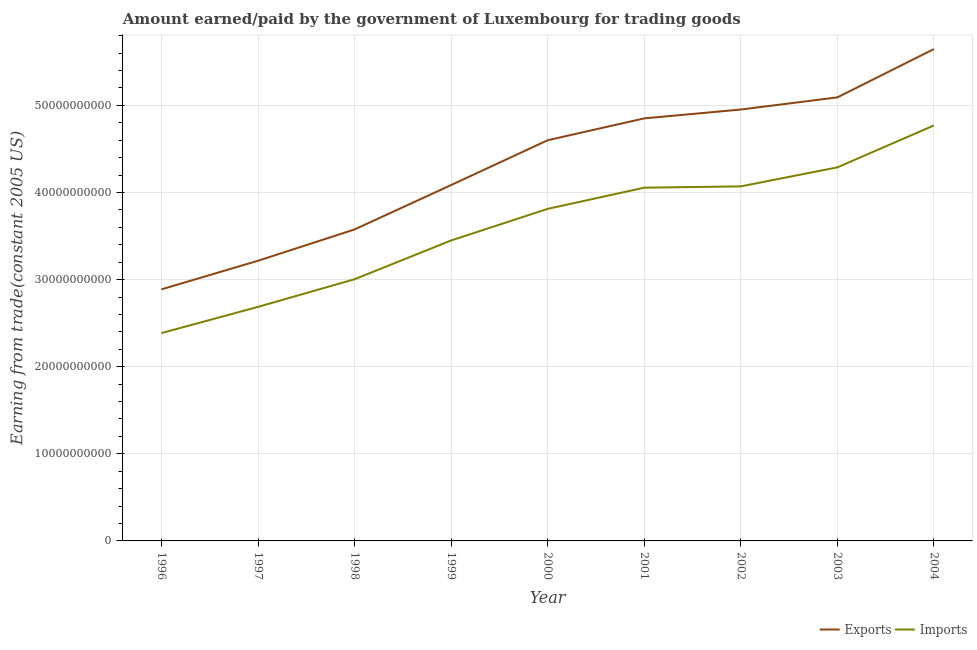Does the line corresponding to amount earned from exports intersect with the line corresponding to amount paid for imports?
Offer a terse response. No. What is the amount paid for imports in 1996?
Provide a succinct answer. 2.39e+1. Across all years, what is the maximum amount paid for imports?
Ensure brevity in your answer.  4.77e+1. Across all years, what is the minimum amount paid for imports?
Keep it short and to the point. 2.39e+1. In which year was the amount earned from exports maximum?
Your response must be concise. 2004. In which year was the amount paid for imports minimum?
Keep it short and to the point. 1996. What is the total amount paid for imports in the graph?
Offer a terse response. 3.25e+11. What is the difference between the amount paid for imports in 1996 and that in 1997?
Your answer should be very brief. -3.01e+09. What is the difference between the amount earned from exports in 1999 and the amount paid for imports in 2004?
Your answer should be very brief. -6.84e+09. What is the average amount earned from exports per year?
Keep it short and to the point. 4.32e+1. In the year 1998, what is the difference between the amount earned from exports and amount paid for imports?
Make the answer very short. 5.72e+09. What is the ratio of the amount earned from exports in 1996 to that in 1998?
Make the answer very short. 0.81. Is the amount paid for imports in 2003 less than that in 2004?
Your answer should be very brief. Yes. Is the difference between the amount paid for imports in 2000 and 2002 greater than the difference between the amount earned from exports in 2000 and 2002?
Your answer should be very brief. Yes. What is the difference between the highest and the second highest amount paid for imports?
Your response must be concise. 4.81e+09. What is the difference between the highest and the lowest amount earned from exports?
Make the answer very short. 2.76e+1. In how many years, is the amount paid for imports greater than the average amount paid for imports taken over all years?
Your response must be concise. 5. Is the sum of the amount paid for imports in 1999 and 2004 greater than the maximum amount earned from exports across all years?
Offer a very short reply. Yes. Is the amount paid for imports strictly greater than the amount earned from exports over the years?
Provide a succinct answer. No. What is the difference between two consecutive major ticks on the Y-axis?
Offer a terse response. 1.00e+1. Are the values on the major ticks of Y-axis written in scientific E-notation?
Provide a short and direct response. No. How many legend labels are there?
Offer a terse response. 2. What is the title of the graph?
Your answer should be very brief. Amount earned/paid by the government of Luxembourg for trading goods. Does "% of gross capital formation" appear as one of the legend labels in the graph?
Provide a succinct answer. No. What is the label or title of the Y-axis?
Make the answer very short. Earning from trade(constant 2005 US). What is the Earning from trade(constant 2005 US) in Exports in 1996?
Your answer should be compact. 2.89e+1. What is the Earning from trade(constant 2005 US) in Imports in 1996?
Your answer should be very brief. 2.39e+1. What is the Earning from trade(constant 2005 US) in Exports in 1997?
Make the answer very short. 3.22e+1. What is the Earning from trade(constant 2005 US) in Imports in 1997?
Ensure brevity in your answer.  2.69e+1. What is the Earning from trade(constant 2005 US) in Exports in 1998?
Give a very brief answer. 3.58e+1. What is the Earning from trade(constant 2005 US) of Imports in 1998?
Your response must be concise. 3.00e+1. What is the Earning from trade(constant 2005 US) of Exports in 1999?
Make the answer very short. 4.09e+1. What is the Earning from trade(constant 2005 US) in Imports in 1999?
Your response must be concise. 3.45e+1. What is the Earning from trade(constant 2005 US) of Exports in 2000?
Keep it short and to the point. 4.60e+1. What is the Earning from trade(constant 2005 US) in Imports in 2000?
Provide a succinct answer. 3.81e+1. What is the Earning from trade(constant 2005 US) of Exports in 2001?
Offer a very short reply. 4.85e+1. What is the Earning from trade(constant 2005 US) of Imports in 2001?
Your response must be concise. 4.06e+1. What is the Earning from trade(constant 2005 US) in Exports in 2002?
Provide a succinct answer. 4.95e+1. What is the Earning from trade(constant 2005 US) of Imports in 2002?
Your answer should be very brief. 4.07e+1. What is the Earning from trade(constant 2005 US) of Exports in 2003?
Keep it short and to the point. 5.09e+1. What is the Earning from trade(constant 2005 US) of Imports in 2003?
Make the answer very short. 4.29e+1. What is the Earning from trade(constant 2005 US) of Exports in 2004?
Offer a terse response. 5.65e+1. What is the Earning from trade(constant 2005 US) of Imports in 2004?
Give a very brief answer. 4.77e+1. Across all years, what is the maximum Earning from trade(constant 2005 US) in Exports?
Your response must be concise. 5.65e+1. Across all years, what is the maximum Earning from trade(constant 2005 US) of Imports?
Ensure brevity in your answer.  4.77e+1. Across all years, what is the minimum Earning from trade(constant 2005 US) in Exports?
Your response must be concise. 2.89e+1. Across all years, what is the minimum Earning from trade(constant 2005 US) in Imports?
Your answer should be compact. 2.39e+1. What is the total Earning from trade(constant 2005 US) in Exports in the graph?
Offer a terse response. 3.89e+11. What is the total Earning from trade(constant 2005 US) in Imports in the graph?
Give a very brief answer. 3.25e+11. What is the difference between the Earning from trade(constant 2005 US) of Exports in 1996 and that in 1997?
Make the answer very short. -3.28e+09. What is the difference between the Earning from trade(constant 2005 US) in Imports in 1996 and that in 1997?
Ensure brevity in your answer.  -3.01e+09. What is the difference between the Earning from trade(constant 2005 US) in Exports in 1996 and that in 1998?
Make the answer very short. -6.88e+09. What is the difference between the Earning from trade(constant 2005 US) in Imports in 1996 and that in 1998?
Your answer should be very brief. -6.18e+09. What is the difference between the Earning from trade(constant 2005 US) of Exports in 1996 and that in 1999?
Your answer should be compact. -1.20e+1. What is the difference between the Earning from trade(constant 2005 US) of Imports in 1996 and that in 1999?
Ensure brevity in your answer.  -1.06e+1. What is the difference between the Earning from trade(constant 2005 US) in Exports in 1996 and that in 2000?
Make the answer very short. -1.71e+1. What is the difference between the Earning from trade(constant 2005 US) of Imports in 1996 and that in 2000?
Offer a terse response. -1.43e+1. What is the difference between the Earning from trade(constant 2005 US) of Exports in 1996 and that in 2001?
Provide a short and direct response. -1.96e+1. What is the difference between the Earning from trade(constant 2005 US) of Imports in 1996 and that in 2001?
Make the answer very short. -1.67e+1. What is the difference between the Earning from trade(constant 2005 US) in Exports in 1996 and that in 2002?
Ensure brevity in your answer.  -2.06e+1. What is the difference between the Earning from trade(constant 2005 US) of Imports in 1996 and that in 2002?
Give a very brief answer. -1.68e+1. What is the difference between the Earning from trade(constant 2005 US) of Exports in 1996 and that in 2003?
Provide a short and direct response. -2.20e+1. What is the difference between the Earning from trade(constant 2005 US) in Imports in 1996 and that in 2003?
Ensure brevity in your answer.  -1.90e+1. What is the difference between the Earning from trade(constant 2005 US) of Exports in 1996 and that in 2004?
Your answer should be compact. -2.76e+1. What is the difference between the Earning from trade(constant 2005 US) of Imports in 1996 and that in 2004?
Your answer should be very brief. -2.38e+1. What is the difference between the Earning from trade(constant 2005 US) in Exports in 1997 and that in 1998?
Keep it short and to the point. -3.59e+09. What is the difference between the Earning from trade(constant 2005 US) of Imports in 1997 and that in 1998?
Provide a short and direct response. -3.17e+09. What is the difference between the Earning from trade(constant 2005 US) in Exports in 1997 and that in 1999?
Your answer should be compact. -8.69e+09. What is the difference between the Earning from trade(constant 2005 US) in Imports in 1997 and that in 1999?
Your response must be concise. -7.63e+09. What is the difference between the Earning from trade(constant 2005 US) of Exports in 1997 and that in 2000?
Your answer should be very brief. -1.38e+1. What is the difference between the Earning from trade(constant 2005 US) of Imports in 1997 and that in 2000?
Your response must be concise. -1.13e+1. What is the difference between the Earning from trade(constant 2005 US) of Exports in 1997 and that in 2001?
Your answer should be compact. -1.63e+1. What is the difference between the Earning from trade(constant 2005 US) of Imports in 1997 and that in 2001?
Ensure brevity in your answer.  -1.37e+1. What is the difference between the Earning from trade(constant 2005 US) of Exports in 1997 and that in 2002?
Your answer should be compact. -1.74e+1. What is the difference between the Earning from trade(constant 2005 US) in Imports in 1997 and that in 2002?
Give a very brief answer. -1.38e+1. What is the difference between the Earning from trade(constant 2005 US) in Exports in 1997 and that in 2003?
Offer a very short reply. -1.88e+1. What is the difference between the Earning from trade(constant 2005 US) of Imports in 1997 and that in 2003?
Offer a very short reply. -1.60e+1. What is the difference between the Earning from trade(constant 2005 US) in Exports in 1997 and that in 2004?
Ensure brevity in your answer.  -2.43e+1. What is the difference between the Earning from trade(constant 2005 US) in Imports in 1997 and that in 2004?
Give a very brief answer. -2.08e+1. What is the difference between the Earning from trade(constant 2005 US) of Exports in 1998 and that in 1999?
Your answer should be very brief. -5.10e+09. What is the difference between the Earning from trade(constant 2005 US) of Imports in 1998 and that in 1999?
Offer a very short reply. -4.45e+09. What is the difference between the Earning from trade(constant 2005 US) of Exports in 1998 and that in 2000?
Offer a terse response. -1.02e+1. What is the difference between the Earning from trade(constant 2005 US) in Imports in 1998 and that in 2000?
Keep it short and to the point. -8.08e+09. What is the difference between the Earning from trade(constant 2005 US) of Exports in 1998 and that in 2001?
Give a very brief answer. -1.28e+1. What is the difference between the Earning from trade(constant 2005 US) in Imports in 1998 and that in 2001?
Give a very brief answer. -1.05e+1. What is the difference between the Earning from trade(constant 2005 US) of Exports in 1998 and that in 2002?
Provide a succinct answer. -1.38e+1. What is the difference between the Earning from trade(constant 2005 US) of Imports in 1998 and that in 2002?
Your answer should be compact. -1.07e+1. What is the difference between the Earning from trade(constant 2005 US) of Exports in 1998 and that in 2003?
Offer a very short reply. -1.52e+1. What is the difference between the Earning from trade(constant 2005 US) in Imports in 1998 and that in 2003?
Make the answer very short. -1.28e+1. What is the difference between the Earning from trade(constant 2005 US) in Exports in 1998 and that in 2004?
Provide a short and direct response. -2.07e+1. What is the difference between the Earning from trade(constant 2005 US) of Imports in 1998 and that in 2004?
Make the answer very short. -1.77e+1. What is the difference between the Earning from trade(constant 2005 US) in Exports in 1999 and that in 2000?
Offer a terse response. -5.15e+09. What is the difference between the Earning from trade(constant 2005 US) of Imports in 1999 and that in 2000?
Offer a terse response. -3.63e+09. What is the difference between the Earning from trade(constant 2005 US) in Exports in 1999 and that in 2001?
Your answer should be very brief. -7.65e+09. What is the difference between the Earning from trade(constant 2005 US) of Imports in 1999 and that in 2001?
Make the answer very short. -6.06e+09. What is the difference between the Earning from trade(constant 2005 US) of Exports in 1999 and that in 2002?
Ensure brevity in your answer.  -8.67e+09. What is the difference between the Earning from trade(constant 2005 US) in Imports in 1999 and that in 2002?
Keep it short and to the point. -6.21e+09. What is the difference between the Earning from trade(constant 2005 US) of Exports in 1999 and that in 2003?
Provide a succinct answer. -1.01e+1. What is the difference between the Earning from trade(constant 2005 US) of Imports in 1999 and that in 2003?
Provide a succinct answer. -8.39e+09. What is the difference between the Earning from trade(constant 2005 US) of Exports in 1999 and that in 2004?
Your answer should be very brief. -1.56e+1. What is the difference between the Earning from trade(constant 2005 US) in Imports in 1999 and that in 2004?
Make the answer very short. -1.32e+1. What is the difference between the Earning from trade(constant 2005 US) of Exports in 2000 and that in 2001?
Your answer should be compact. -2.51e+09. What is the difference between the Earning from trade(constant 2005 US) of Imports in 2000 and that in 2001?
Provide a short and direct response. -2.43e+09. What is the difference between the Earning from trade(constant 2005 US) of Exports in 2000 and that in 2002?
Your answer should be compact. -3.52e+09. What is the difference between the Earning from trade(constant 2005 US) in Imports in 2000 and that in 2002?
Ensure brevity in your answer.  -2.58e+09. What is the difference between the Earning from trade(constant 2005 US) in Exports in 2000 and that in 2003?
Ensure brevity in your answer.  -4.92e+09. What is the difference between the Earning from trade(constant 2005 US) of Imports in 2000 and that in 2003?
Ensure brevity in your answer.  -4.76e+09. What is the difference between the Earning from trade(constant 2005 US) in Exports in 2000 and that in 2004?
Provide a short and direct response. -1.05e+1. What is the difference between the Earning from trade(constant 2005 US) of Imports in 2000 and that in 2004?
Your answer should be very brief. -9.58e+09. What is the difference between the Earning from trade(constant 2005 US) of Exports in 2001 and that in 2002?
Your answer should be compact. -1.02e+09. What is the difference between the Earning from trade(constant 2005 US) in Imports in 2001 and that in 2002?
Offer a terse response. -1.50e+08. What is the difference between the Earning from trade(constant 2005 US) in Exports in 2001 and that in 2003?
Your answer should be compact. -2.41e+09. What is the difference between the Earning from trade(constant 2005 US) of Imports in 2001 and that in 2003?
Provide a succinct answer. -2.33e+09. What is the difference between the Earning from trade(constant 2005 US) in Exports in 2001 and that in 2004?
Keep it short and to the point. -7.96e+09. What is the difference between the Earning from trade(constant 2005 US) of Imports in 2001 and that in 2004?
Provide a short and direct response. -7.14e+09. What is the difference between the Earning from trade(constant 2005 US) in Exports in 2002 and that in 2003?
Make the answer very short. -1.39e+09. What is the difference between the Earning from trade(constant 2005 US) in Imports in 2002 and that in 2003?
Your answer should be compact. -2.18e+09. What is the difference between the Earning from trade(constant 2005 US) of Exports in 2002 and that in 2004?
Give a very brief answer. -6.94e+09. What is the difference between the Earning from trade(constant 2005 US) in Imports in 2002 and that in 2004?
Provide a short and direct response. -6.99e+09. What is the difference between the Earning from trade(constant 2005 US) of Exports in 2003 and that in 2004?
Ensure brevity in your answer.  -5.55e+09. What is the difference between the Earning from trade(constant 2005 US) of Imports in 2003 and that in 2004?
Make the answer very short. -4.81e+09. What is the difference between the Earning from trade(constant 2005 US) of Exports in 1996 and the Earning from trade(constant 2005 US) of Imports in 1997?
Offer a very short reply. 2.01e+09. What is the difference between the Earning from trade(constant 2005 US) in Exports in 1996 and the Earning from trade(constant 2005 US) in Imports in 1998?
Offer a terse response. -1.16e+09. What is the difference between the Earning from trade(constant 2005 US) in Exports in 1996 and the Earning from trade(constant 2005 US) in Imports in 1999?
Offer a very short reply. -5.61e+09. What is the difference between the Earning from trade(constant 2005 US) of Exports in 1996 and the Earning from trade(constant 2005 US) of Imports in 2000?
Offer a terse response. -9.24e+09. What is the difference between the Earning from trade(constant 2005 US) in Exports in 1996 and the Earning from trade(constant 2005 US) in Imports in 2001?
Your answer should be compact. -1.17e+1. What is the difference between the Earning from trade(constant 2005 US) in Exports in 1996 and the Earning from trade(constant 2005 US) in Imports in 2002?
Ensure brevity in your answer.  -1.18e+1. What is the difference between the Earning from trade(constant 2005 US) in Exports in 1996 and the Earning from trade(constant 2005 US) in Imports in 2003?
Offer a very short reply. -1.40e+1. What is the difference between the Earning from trade(constant 2005 US) in Exports in 1996 and the Earning from trade(constant 2005 US) in Imports in 2004?
Offer a terse response. -1.88e+1. What is the difference between the Earning from trade(constant 2005 US) in Exports in 1997 and the Earning from trade(constant 2005 US) in Imports in 1998?
Ensure brevity in your answer.  2.12e+09. What is the difference between the Earning from trade(constant 2005 US) of Exports in 1997 and the Earning from trade(constant 2005 US) of Imports in 1999?
Provide a short and direct response. -2.33e+09. What is the difference between the Earning from trade(constant 2005 US) in Exports in 1997 and the Earning from trade(constant 2005 US) in Imports in 2000?
Provide a short and direct response. -5.96e+09. What is the difference between the Earning from trade(constant 2005 US) of Exports in 1997 and the Earning from trade(constant 2005 US) of Imports in 2001?
Make the answer very short. -8.39e+09. What is the difference between the Earning from trade(constant 2005 US) of Exports in 1997 and the Earning from trade(constant 2005 US) of Imports in 2002?
Your answer should be compact. -8.54e+09. What is the difference between the Earning from trade(constant 2005 US) of Exports in 1997 and the Earning from trade(constant 2005 US) of Imports in 2003?
Provide a short and direct response. -1.07e+1. What is the difference between the Earning from trade(constant 2005 US) of Exports in 1997 and the Earning from trade(constant 2005 US) of Imports in 2004?
Keep it short and to the point. -1.55e+1. What is the difference between the Earning from trade(constant 2005 US) in Exports in 1998 and the Earning from trade(constant 2005 US) in Imports in 1999?
Make the answer very short. 1.26e+09. What is the difference between the Earning from trade(constant 2005 US) of Exports in 1998 and the Earning from trade(constant 2005 US) of Imports in 2000?
Keep it short and to the point. -2.36e+09. What is the difference between the Earning from trade(constant 2005 US) of Exports in 1998 and the Earning from trade(constant 2005 US) of Imports in 2001?
Give a very brief answer. -4.79e+09. What is the difference between the Earning from trade(constant 2005 US) in Exports in 1998 and the Earning from trade(constant 2005 US) in Imports in 2002?
Your answer should be compact. -4.94e+09. What is the difference between the Earning from trade(constant 2005 US) in Exports in 1998 and the Earning from trade(constant 2005 US) in Imports in 2003?
Offer a very short reply. -7.13e+09. What is the difference between the Earning from trade(constant 2005 US) of Exports in 1998 and the Earning from trade(constant 2005 US) of Imports in 2004?
Ensure brevity in your answer.  -1.19e+1. What is the difference between the Earning from trade(constant 2005 US) in Exports in 1999 and the Earning from trade(constant 2005 US) in Imports in 2000?
Make the answer very short. 2.73e+09. What is the difference between the Earning from trade(constant 2005 US) of Exports in 1999 and the Earning from trade(constant 2005 US) of Imports in 2001?
Provide a short and direct response. 3.02e+08. What is the difference between the Earning from trade(constant 2005 US) in Exports in 1999 and the Earning from trade(constant 2005 US) in Imports in 2002?
Provide a succinct answer. 1.51e+08. What is the difference between the Earning from trade(constant 2005 US) in Exports in 1999 and the Earning from trade(constant 2005 US) in Imports in 2003?
Make the answer very short. -2.03e+09. What is the difference between the Earning from trade(constant 2005 US) in Exports in 1999 and the Earning from trade(constant 2005 US) in Imports in 2004?
Your response must be concise. -6.84e+09. What is the difference between the Earning from trade(constant 2005 US) of Exports in 2000 and the Earning from trade(constant 2005 US) of Imports in 2001?
Offer a very short reply. 5.45e+09. What is the difference between the Earning from trade(constant 2005 US) of Exports in 2000 and the Earning from trade(constant 2005 US) of Imports in 2002?
Make the answer very short. 5.30e+09. What is the difference between the Earning from trade(constant 2005 US) in Exports in 2000 and the Earning from trade(constant 2005 US) in Imports in 2003?
Provide a succinct answer. 3.12e+09. What is the difference between the Earning from trade(constant 2005 US) of Exports in 2000 and the Earning from trade(constant 2005 US) of Imports in 2004?
Provide a succinct answer. -1.70e+09. What is the difference between the Earning from trade(constant 2005 US) of Exports in 2001 and the Earning from trade(constant 2005 US) of Imports in 2002?
Give a very brief answer. 7.81e+09. What is the difference between the Earning from trade(constant 2005 US) of Exports in 2001 and the Earning from trade(constant 2005 US) of Imports in 2003?
Your response must be concise. 5.62e+09. What is the difference between the Earning from trade(constant 2005 US) in Exports in 2001 and the Earning from trade(constant 2005 US) in Imports in 2004?
Ensure brevity in your answer.  8.12e+08. What is the difference between the Earning from trade(constant 2005 US) in Exports in 2002 and the Earning from trade(constant 2005 US) in Imports in 2003?
Provide a succinct answer. 6.64e+09. What is the difference between the Earning from trade(constant 2005 US) of Exports in 2002 and the Earning from trade(constant 2005 US) of Imports in 2004?
Offer a terse response. 1.83e+09. What is the difference between the Earning from trade(constant 2005 US) in Exports in 2003 and the Earning from trade(constant 2005 US) in Imports in 2004?
Make the answer very short. 3.22e+09. What is the average Earning from trade(constant 2005 US) in Exports per year?
Your answer should be very brief. 4.32e+1. What is the average Earning from trade(constant 2005 US) of Imports per year?
Keep it short and to the point. 3.61e+1. In the year 1996, what is the difference between the Earning from trade(constant 2005 US) in Exports and Earning from trade(constant 2005 US) in Imports?
Your response must be concise. 5.02e+09. In the year 1997, what is the difference between the Earning from trade(constant 2005 US) in Exports and Earning from trade(constant 2005 US) in Imports?
Your answer should be compact. 5.30e+09. In the year 1998, what is the difference between the Earning from trade(constant 2005 US) of Exports and Earning from trade(constant 2005 US) of Imports?
Your response must be concise. 5.72e+09. In the year 1999, what is the difference between the Earning from trade(constant 2005 US) in Exports and Earning from trade(constant 2005 US) in Imports?
Your response must be concise. 6.36e+09. In the year 2000, what is the difference between the Earning from trade(constant 2005 US) of Exports and Earning from trade(constant 2005 US) of Imports?
Your response must be concise. 7.88e+09. In the year 2001, what is the difference between the Earning from trade(constant 2005 US) in Exports and Earning from trade(constant 2005 US) in Imports?
Your answer should be very brief. 7.96e+09. In the year 2002, what is the difference between the Earning from trade(constant 2005 US) of Exports and Earning from trade(constant 2005 US) of Imports?
Your response must be concise. 8.82e+09. In the year 2003, what is the difference between the Earning from trade(constant 2005 US) in Exports and Earning from trade(constant 2005 US) in Imports?
Give a very brief answer. 8.03e+09. In the year 2004, what is the difference between the Earning from trade(constant 2005 US) in Exports and Earning from trade(constant 2005 US) in Imports?
Keep it short and to the point. 8.77e+09. What is the ratio of the Earning from trade(constant 2005 US) in Exports in 1996 to that in 1997?
Your answer should be very brief. 0.9. What is the ratio of the Earning from trade(constant 2005 US) in Imports in 1996 to that in 1997?
Ensure brevity in your answer.  0.89. What is the ratio of the Earning from trade(constant 2005 US) of Exports in 1996 to that in 1998?
Provide a succinct answer. 0.81. What is the ratio of the Earning from trade(constant 2005 US) in Imports in 1996 to that in 1998?
Give a very brief answer. 0.79. What is the ratio of the Earning from trade(constant 2005 US) of Exports in 1996 to that in 1999?
Offer a very short reply. 0.71. What is the ratio of the Earning from trade(constant 2005 US) of Imports in 1996 to that in 1999?
Your answer should be compact. 0.69. What is the ratio of the Earning from trade(constant 2005 US) in Exports in 1996 to that in 2000?
Keep it short and to the point. 0.63. What is the ratio of the Earning from trade(constant 2005 US) of Imports in 1996 to that in 2000?
Your response must be concise. 0.63. What is the ratio of the Earning from trade(constant 2005 US) of Exports in 1996 to that in 2001?
Ensure brevity in your answer.  0.6. What is the ratio of the Earning from trade(constant 2005 US) in Imports in 1996 to that in 2001?
Provide a succinct answer. 0.59. What is the ratio of the Earning from trade(constant 2005 US) in Exports in 1996 to that in 2002?
Provide a short and direct response. 0.58. What is the ratio of the Earning from trade(constant 2005 US) of Imports in 1996 to that in 2002?
Provide a succinct answer. 0.59. What is the ratio of the Earning from trade(constant 2005 US) of Exports in 1996 to that in 2003?
Keep it short and to the point. 0.57. What is the ratio of the Earning from trade(constant 2005 US) in Imports in 1996 to that in 2003?
Provide a short and direct response. 0.56. What is the ratio of the Earning from trade(constant 2005 US) of Exports in 1996 to that in 2004?
Provide a succinct answer. 0.51. What is the ratio of the Earning from trade(constant 2005 US) in Imports in 1996 to that in 2004?
Offer a terse response. 0.5. What is the ratio of the Earning from trade(constant 2005 US) of Exports in 1997 to that in 1998?
Your answer should be compact. 0.9. What is the ratio of the Earning from trade(constant 2005 US) of Imports in 1997 to that in 1998?
Offer a terse response. 0.89. What is the ratio of the Earning from trade(constant 2005 US) of Exports in 1997 to that in 1999?
Ensure brevity in your answer.  0.79. What is the ratio of the Earning from trade(constant 2005 US) in Imports in 1997 to that in 1999?
Offer a very short reply. 0.78. What is the ratio of the Earning from trade(constant 2005 US) of Exports in 1997 to that in 2000?
Ensure brevity in your answer.  0.7. What is the ratio of the Earning from trade(constant 2005 US) in Imports in 1997 to that in 2000?
Make the answer very short. 0.7. What is the ratio of the Earning from trade(constant 2005 US) in Exports in 1997 to that in 2001?
Your answer should be compact. 0.66. What is the ratio of the Earning from trade(constant 2005 US) in Imports in 1997 to that in 2001?
Your answer should be compact. 0.66. What is the ratio of the Earning from trade(constant 2005 US) of Exports in 1997 to that in 2002?
Your answer should be very brief. 0.65. What is the ratio of the Earning from trade(constant 2005 US) in Imports in 1997 to that in 2002?
Offer a terse response. 0.66. What is the ratio of the Earning from trade(constant 2005 US) in Exports in 1997 to that in 2003?
Offer a very short reply. 0.63. What is the ratio of the Earning from trade(constant 2005 US) in Imports in 1997 to that in 2003?
Give a very brief answer. 0.63. What is the ratio of the Earning from trade(constant 2005 US) in Exports in 1997 to that in 2004?
Provide a short and direct response. 0.57. What is the ratio of the Earning from trade(constant 2005 US) of Imports in 1997 to that in 2004?
Provide a short and direct response. 0.56. What is the ratio of the Earning from trade(constant 2005 US) of Exports in 1998 to that in 1999?
Provide a succinct answer. 0.88. What is the ratio of the Earning from trade(constant 2005 US) of Imports in 1998 to that in 1999?
Offer a very short reply. 0.87. What is the ratio of the Earning from trade(constant 2005 US) of Exports in 1998 to that in 2000?
Offer a very short reply. 0.78. What is the ratio of the Earning from trade(constant 2005 US) of Imports in 1998 to that in 2000?
Provide a succinct answer. 0.79. What is the ratio of the Earning from trade(constant 2005 US) in Exports in 1998 to that in 2001?
Give a very brief answer. 0.74. What is the ratio of the Earning from trade(constant 2005 US) in Imports in 1998 to that in 2001?
Offer a terse response. 0.74. What is the ratio of the Earning from trade(constant 2005 US) of Exports in 1998 to that in 2002?
Offer a very short reply. 0.72. What is the ratio of the Earning from trade(constant 2005 US) of Imports in 1998 to that in 2002?
Ensure brevity in your answer.  0.74. What is the ratio of the Earning from trade(constant 2005 US) in Exports in 1998 to that in 2003?
Ensure brevity in your answer.  0.7. What is the ratio of the Earning from trade(constant 2005 US) of Imports in 1998 to that in 2003?
Ensure brevity in your answer.  0.7. What is the ratio of the Earning from trade(constant 2005 US) of Exports in 1998 to that in 2004?
Provide a short and direct response. 0.63. What is the ratio of the Earning from trade(constant 2005 US) of Imports in 1998 to that in 2004?
Offer a terse response. 0.63. What is the ratio of the Earning from trade(constant 2005 US) in Exports in 1999 to that in 2000?
Provide a short and direct response. 0.89. What is the ratio of the Earning from trade(constant 2005 US) in Imports in 1999 to that in 2000?
Make the answer very short. 0.9. What is the ratio of the Earning from trade(constant 2005 US) of Exports in 1999 to that in 2001?
Give a very brief answer. 0.84. What is the ratio of the Earning from trade(constant 2005 US) in Imports in 1999 to that in 2001?
Provide a succinct answer. 0.85. What is the ratio of the Earning from trade(constant 2005 US) in Exports in 1999 to that in 2002?
Offer a terse response. 0.82. What is the ratio of the Earning from trade(constant 2005 US) in Imports in 1999 to that in 2002?
Offer a very short reply. 0.85. What is the ratio of the Earning from trade(constant 2005 US) of Exports in 1999 to that in 2003?
Give a very brief answer. 0.8. What is the ratio of the Earning from trade(constant 2005 US) of Imports in 1999 to that in 2003?
Your answer should be very brief. 0.8. What is the ratio of the Earning from trade(constant 2005 US) in Exports in 1999 to that in 2004?
Make the answer very short. 0.72. What is the ratio of the Earning from trade(constant 2005 US) of Imports in 1999 to that in 2004?
Offer a terse response. 0.72. What is the ratio of the Earning from trade(constant 2005 US) in Exports in 2000 to that in 2001?
Make the answer very short. 0.95. What is the ratio of the Earning from trade(constant 2005 US) in Exports in 2000 to that in 2002?
Your response must be concise. 0.93. What is the ratio of the Earning from trade(constant 2005 US) of Imports in 2000 to that in 2002?
Your answer should be very brief. 0.94. What is the ratio of the Earning from trade(constant 2005 US) in Exports in 2000 to that in 2003?
Your response must be concise. 0.9. What is the ratio of the Earning from trade(constant 2005 US) in Imports in 2000 to that in 2003?
Your response must be concise. 0.89. What is the ratio of the Earning from trade(constant 2005 US) of Exports in 2000 to that in 2004?
Provide a short and direct response. 0.81. What is the ratio of the Earning from trade(constant 2005 US) of Imports in 2000 to that in 2004?
Offer a very short reply. 0.8. What is the ratio of the Earning from trade(constant 2005 US) of Exports in 2001 to that in 2002?
Your answer should be very brief. 0.98. What is the ratio of the Earning from trade(constant 2005 US) in Imports in 2001 to that in 2002?
Your response must be concise. 1. What is the ratio of the Earning from trade(constant 2005 US) of Exports in 2001 to that in 2003?
Provide a short and direct response. 0.95. What is the ratio of the Earning from trade(constant 2005 US) in Imports in 2001 to that in 2003?
Your answer should be compact. 0.95. What is the ratio of the Earning from trade(constant 2005 US) of Exports in 2001 to that in 2004?
Make the answer very short. 0.86. What is the ratio of the Earning from trade(constant 2005 US) of Imports in 2001 to that in 2004?
Your answer should be very brief. 0.85. What is the ratio of the Earning from trade(constant 2005 US) of Exports in 2002 to that in 2003?
Provide a succinct answer. 0.97. What is the ratio of the Earning from trade(constant 2005 US) of Imports in 2002 to that in 2003?
Give a very brief answer. 0.95. What is the ratio of the Earning from trade(constant 2005 US) in Exports in 2002 to that in 2004?
Provide a short and direct response. 0.88. What is the ratio of the Earning from trade(constant 2005 US) of Imports in 2002 to that in 2004?
Provide a succinct answer. 0.85. What is the ratio of the Earning from trade(constant 2005 US) in Exports in 2003 to that in 2004?
Ensure brevity in your answer.  0.9. What is the ratio of the Earning from trade(constant 2005 US) in Imports in 2003 to that in 2004?
Your answer should be compact. 0.9. What is the difference between the highest and the second highest Earning from trade(constant 2005 US) of Exports?
Your answer should be compact. 5.55e+09. What is the difference between the highest and the second highest Earning from trade(constant 2005 US) in Imports?
Offer a terse response. 4.81e+09. What is the difference between the highest and the lowest Earning from trade(constant 2005 US) in Exports?
Provide a succinct answer. 2.76e+1. What is the difference between the highest and the lowest Earning from trade(constant 2005 US) in Imports?
Your answer should be compact. 2.38e+1. 